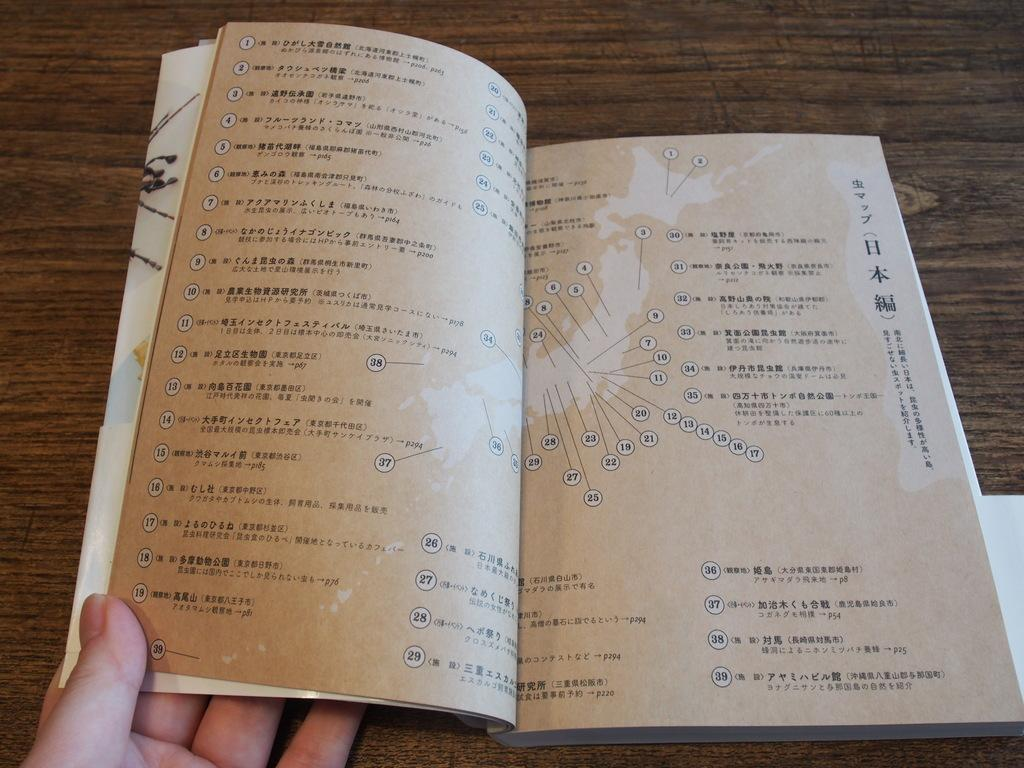What object is present on the table in the image? There is a book on the table in the image. What is the book being used for in the image? The book is being held by a person's hand in the image. Can you describe the person's hand in the image? The person's hand is visible in the image, holding the book. What type of wire is being used for payment in the image? There is no wire or payment transaction depicted in the image; it only shows a book on a table and a person's hand holding the book. 